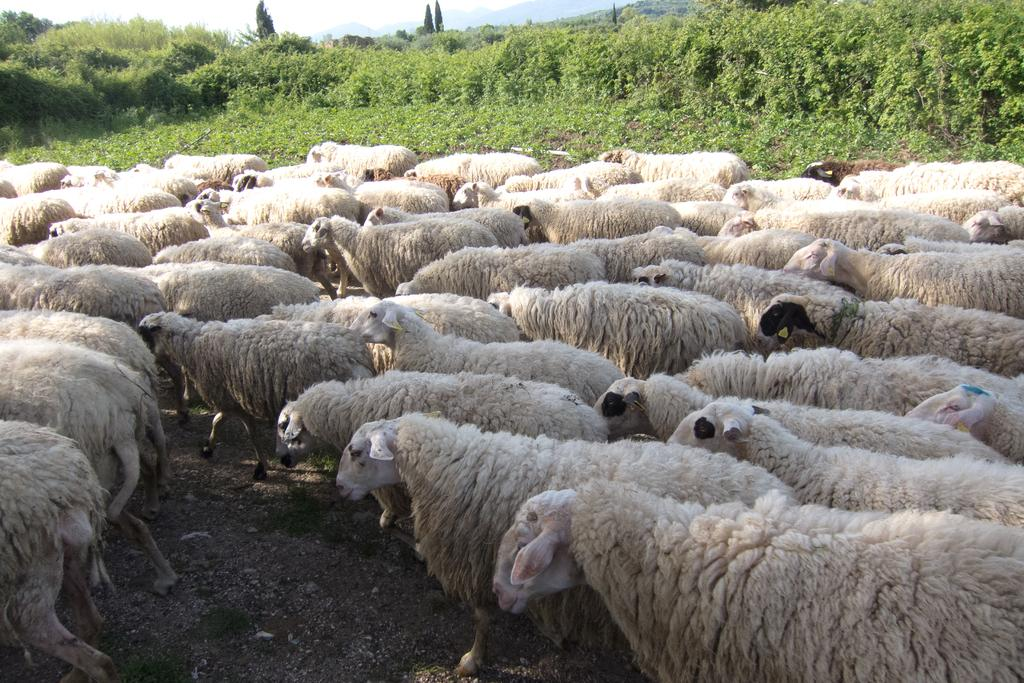What animals are present in the image? There is a herd of sheep in the image. What color are the sheep? The sheep are white in color. What type of vegetation can be seen in the image? There are trees visible in the image. How would you describe the sky in the image? The sky is cloudy in the image. What type of reason can be seen in the image? There is no reason present in the image; it features a herd of sheep, trees, and a cloudy sky. Can you see the sea in the image? No, the sea is not visible in the image. 